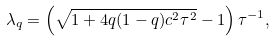Convert formula to latex. <formula><loc_0><loc_0><loc_500><loc_500>\lambda _ { q } = \left ( \sqrt { 1 + 4 q ( 1 - q ) c ^ { 2 } \tau ^ { 2 } } - 1 \right ) \tau ^ { - 1 } ,</formula> 